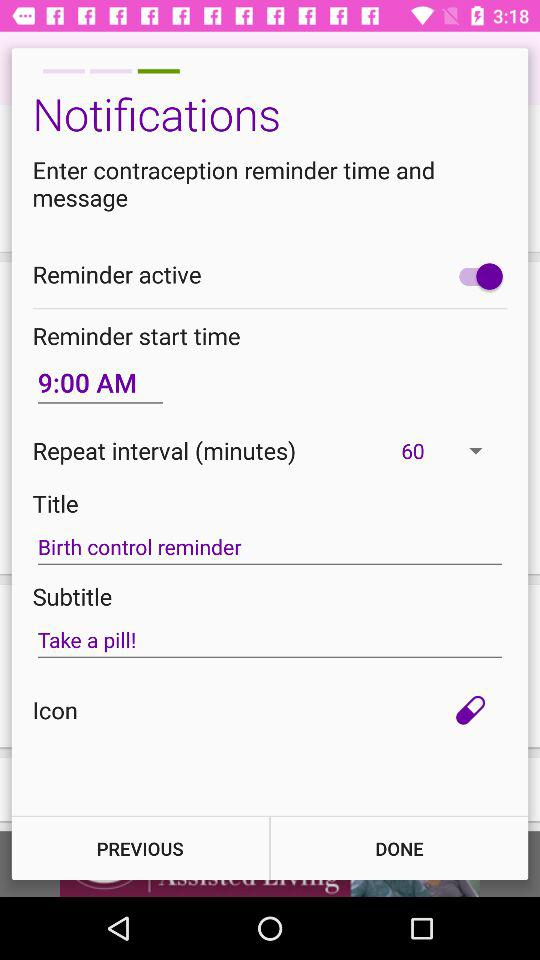Which setting option has a birth control reminder written on it? The setting option that has a birth control reminder written on it is "Title". 